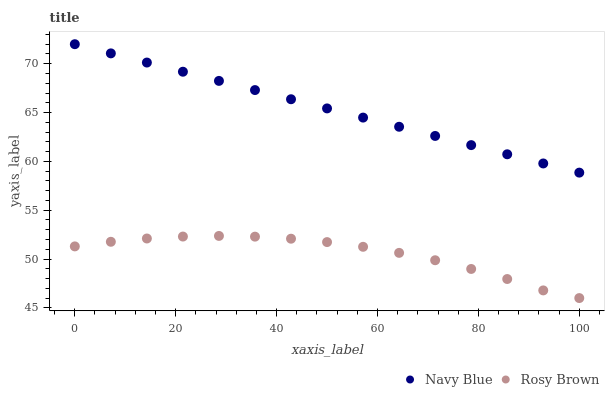Does Rosy Brown have the minimum area under the curve?
Answer yes or no. Yes. Does Navy Blue have the maximum area under the curve?
Answer yes or no. Yes. Does Rosy Brown have the maximum area under the curve?
Answer yes or no. No. Is Navy Blue the smoothest?
Answer yes or no. Yes. Is Rosy Brown the roughest?
Answer yes or no. Yes. Is Rosy Brown the smoothest?
Answer yes or no. No. Does Rosy Brown have the lowest value?
Answer yes or no. Yes. Does Navy Blue have the highest value?
Answer yes or no. Yes. Does Rosy Brown have the highest value?
Answer yes or no. No. Is Rosy Brown less than Navy Blue?
Answer yes or no. Yes. Is Navy Blue greater than Rosy Brown?
Answer yes or no. Yes. Does Rosy Brown intersect Navy Blue?
Answer yes or no. No. 